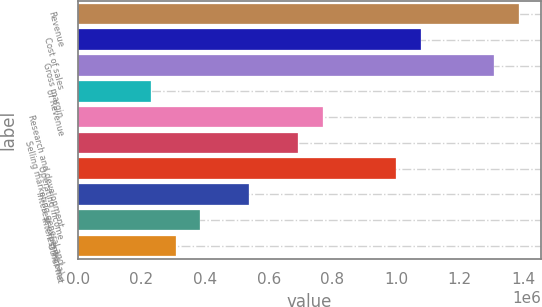<chart> <loc_0><loc_0><loc_500><loc_500><bar_chart><fcel>Revenue<fcel>Cost of sales<fcel>Gross margin<fcel>of Revenue<fcel>Research and development<fcel>Selling marketing general and<fcel>Operating income<fcel>Interest expense (a)<fcel>Interest income<fcel>Other net<nl><fcel>1.38497e+06<fcel>1.0772e+06<fcel>1.30803e+06<fcel>230829<fcel>769429<fcel>692486<fcel>1.00026e+06<fcel>538600<fcel>384715<fcel>307772<nl></chart> 